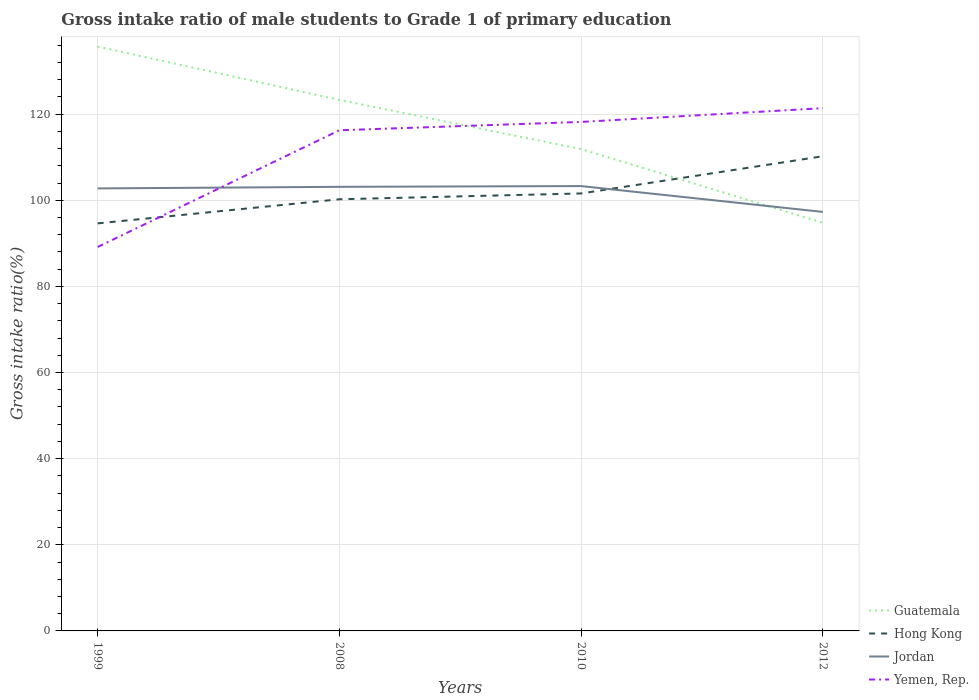Across all years, what is the maximum gross intake ratio in Hong Kong?
Your answer should be very brief. 94.64. In which year was the gross intake ratio in Guatemala maximum?
Offer a very short reply. 2012. What is the total gross intake ratio in Hong Kong in the graph?
Ensure brevity in your answer.  -15.59. What is the difference between the highest and the second highest gross intake ratio in Jordan?
Provide a succinct answer. 6. What is the difference between the highest and the lowest gross intake ratio in Yemen, Rep.?
Ensure brevity in your answer.  3. How many lines are there?
Keep it short and to the point. 4. How many years are there in the graph?
Keep it short and to the point. 4. What is the difference between two consecutive major ticks on the Y-axis?
Your answer should be compact. 20. Does the graph contain grids?
Provide a succinct answer. Yes. What is the title of the graph?
Make the answer very short. Gross intake ratio of male students to Grade 1 of primary education. What is the label or title of the Y-axis?
Make the answer very short. Gross intake ratio(%). What is the Gross intake ratio(%) in Guatemala in 1999?
Your answer should be very brief. 135.69. What is the Gross intake ratio(%) in Hong Kong in 1999?
Offer a terse response. 94.64. What is the Gross intake ratio(%) in Jordan in 1999?
Offer a terse response. 102.75. What is the Gross intake ratio(%) in Yemen, Rep. in 1999?
Offer a very short reply. 89.15. What is the Gross intake ratio(%) in Guatemala in 2008?
Offer a terse response. 123.3. What is the Gross intake ratio(%) in Hong Kong in 2008?
Give a very brief answer. 100.24. What is the Gross intake ratio(%) in Jordan in 2008?
Offer a terse response. 103.13. What is the Gross intake ratio(%) in Yemen, Rep. in 2008?
Your response must be concise. 116.26. What is the Gross intake ratio(%) in Guatemala in 2010?
Your response must be concise. 111.89. What is the Gross intake ratio(%) of Hong Kong in 2010?
Provide a succinct answer. 101.59. What is the Gross intake ratio(%) of Jordan in 2010?
Keep it short and to the point. 103.3. What is the Gross intake ratio(%) of Yemen, Rep. in 2010?
Offer a terse response. 118.19. What is the Gross intake ratio(%) in Guatemala in 2012?
Give a very brief answer. 94.78. What is the Gross intake ratio(%) of Hong Kong in 2012?
Your answer should be compact. 110.22. What is the Gross intake ratio(%) of Jordan in 2012?
Provide a succinct answer. 97.3. What is the Gross intake ratio(%) in Yemen, Rep. in 2012?
Your answer should be very brief. 121.39. Across all years, what is the maximum Gross intake ratio(%) in Guatemala?
Keep it short and to the point. 135.69. Across all years, what is the maximum Gross intake ratio(%) in Hong Kong?
Your answer should be very brief. 110.22. Across all years, what is the maximum Gross intake ratio(%) of Jordan?
Offer a very short reply. 103.3. Across all years, what is the maximum Gross intake ratio(%) of Yemen, Rep.?
Your answer should be compact. 121.39. Across all years, what is the minimum Gross intake ratio(%) in Guatemala?
Provide a succinct answer. 94.78. Across all years, what is the minimum Gross intake ratio(%) in Hong Kong?
Your answer should be compact. 94.64. Across all years, what is the minimum Gross intake ratio(%) of Jordan?
Your answer should be very brief. 97.3. Across all years, what is the minimum Gross intake ratio(%) in Yemen, Rep.?
Provide a short and direct response. 89.15. What is the total Gross intake ratio(%) of Guatemala in the graph?
Give a very brief answer. 465.66. What is the total Gross intake ratio(%) in Hong Kong in the graph?
Keep it short and to the point. 406.69. What is the total Gross intake ratio(%) in Jordan in the graph?
Your response must be concise. 406.48. What is the total Gross intake ratio(%) in Yemen, Rep. in the graph?
Give a very brief answer. 445. What is the difference between the Gross intake ratio(%) of Guatemala in 1999 and that in 2008?
Provide a short and direct response. 12.39. What is the difference between the Gross intake ratio(%) in Hong Kong in 1999 and that in 2008?
Your response must be concise. -5.6. What is the difference between the Gross intake ratio(%) of Jordan in 1999 and that in 2008?
Provide a short and direct response. -0.37. What is the difference between the Gross intake ratio(%) in Yemen, Rep. in 1999 and that in 2008?
Your response must be concise. -27.11. What is the difference between the Gross intake ratio(%) of Guatemala in 1999 and that in 2010?
Make the answer very short. 23.8. What is the difference between the Gross intake ratio(%) in Hong Kong in 1999 and that in 2010?
Your response must be concise. -6.95. What is the difference between the Gross intake ratio(%) in Jordan in 1999 and that in 2010?
Provide a short and direct response. -0.55. What is the difference between the Gross intake ratio(%) of Yemen, Rep. in 1999 and that in 2010?
Make the answer very short. -29.04. What is the difference between the Gross intake ratio(%) of Guatemala in 1999 and that in 2012?
Your response must be concise. 40.91. What is the difference between the Gross intake ratio(%) of Hong Kong in 1999 and that in 2012?
Provide a succinct answer. -15.59. What is the difference between the Gross intake ratio(%) of Jordan in 1999 and that in 2012?
Ensure brevity in your answer.  5.46. What is the difference between the Gross intake ratio(%) in Yemen, Rep. in 1999 and that in 2012?
Provide a succinct answer. -32.24. What is the difference between the Gross intake ratio(%) in Guatemala in 2008 and that in 2010?
Make the answer very short. 11.41. What is the difference between the Gross intake ratio(%) in Hong Kong in 2008 and that in 2010?
Provide a short and direct response. -1.35. What is the difference between the Gross intake ratio(%) of Jordan in 2008 and that in 2010?
Your answer should be compact. -0.17. What is the difference between the Gross intake ratio(%) in Yemen, Rep. in 2008 and that in 2010?
Offer a terse response. -1.93. What is the difference between the Gross intake ratio(%) in Guatemala in 2008 and that in 2012?
Provide a short and direct response. 28.53. What is the difference between the Gross intake ratio(%) of Hong Kong in 2008 and that in 2012?
Offer a terse response. -9.99. What is the difference between the Gross intake ratio(%) of Jordan in 2008 and that in 2012?
Give a very brief answer. 5.83. What is the difference between the Gross intake ratio(%) of Yemen, Rep. in 2008 and that in 2012?
Give a very brief answer. -5.13. What is the difference between the Gross intake ratio(%) in Guatemala in 2010 and that in 2012?
Your answer should be very brief. 17.12. What is the difference between the Gross intake ratio(%) of Hong Kong in 2010 and that in 2012?
Make the answer very short. -8.64. What is the difference between the Gross intake ratio(%) in Jordan in 2010 and that in 2012?
Offer a terse response. 6. What is the difference between the Gross intake ratio(%) of Yemen, Rep. in 2010 and that in 2012?
Make the answer very short. -3.2. What is the difference between the Gross intake ratio(%) of Guatemala in 1999 and the Gross intake ratio(%) of Hong Kong in 2008?
Your answer should be very brief. 35.45. What is the difference between the Gross intake ratio(%) of Guatemala in 1999 and the Gross intake ratio(%) of Jordan in 2008?
Offer a terse response. 32.56. What is the difference between the Gross intake ratio(%) of Guatemala in 1999 and the Gross intake ratio(%) of Yemen, Rep. in 2008?
Offer a very short reply. 19.43. What is the difference between the Gross intake ratio(%) of Hong Kong in 1999 and the Gross intake ratio(%) of Jordan in 2008?
Your answer should be very brief. -8.49. What is the difference between the Gross intake ratio(%) in Hong Kong in 1999 and the Gross intake ratio(%) in Yemen, Rep. in 2008?
Provide a short and direct response. -21.62. What is the difference between the Gross intake ratio(%) in Jordan in 1999 and the Gross intake ratio(%) in Yemen, Rep. in 2008?
Provide a succinct answer. -13.51. What is the difference between the Gross intake ratio(%) of Guatemala in 1999 and the Gross intake ratio(%) of Hong Kong in 2010?
Give a very brief answer. 34.1. What is the difference between the Gross intake ratio(%) in Guatemala in 1999 and the Gross intake ratio(%) in Jordan in 2010?
Make the answer very short. 32.39. What is the difference between the Gross intake ratio(%) in Guatemala in 1999 and the Gross intake ratio(%) in Yemen, Rep. in 2010?
Offer a very short reply. 17.5. What is the difference between the Gross intake ratio(%) in Hong Kong in 1999 and the Gross intake ratio(%) in Jordan in 2010?
Provide a succinct answer. -8.66. What is the difference between the Gross intake ratio(%) in Hong Kong in 1999 and the Gross intake ratio(%) in Yemen, Rep. in 2010?
Give a very brief answer. -23.56. What is the difference between the Gross intake ratio(%) of Jordan in 1999 and the Gross intake ratio(%) of Yemen, Rep. in 2010?
Provide a short and direct response. -15.44. What is the difference between the Gross intake ratio(%) in Guatemala in 1999 and the Gross intake ratio(%) in Hong Kong in 2012?
Provide a short and direct response. 25.47. What is the difference between the Gross intake ratio(%) in Guatemala in 1999 and the Gross intake ratio(%) in Jordan in 2012?
Offer a very short reply. 38.39. What is the difference between the Gross intake ratio(%) of Guatemala in 1999 and the Gross intake ratio(%) of Yemen, Rep. in 2012?
Ensure brevity in your answer.  14.3. What is the difference between the Gross intake ratio(%) in Hong Kong in 1999 and the Gross intake ratio(%) in Jordan in 2012?
Your response must be concise. -2.66. What is the difference between the Gross intake ratio(%) in Hong Kong in 1999 and the Gross intake ratio(%) in Yemen, Rep. in 2012?
Your answer should be very brief. -26.76. What is the difference between the Gross intake ratio(%) of Jordan in 1999 and the Gross intake ratio(%) of Yemen, Rep. in 2012?
Provide a succinct answer. -18.64. What is the difference between the Gross intake ratio(%) in Guatemala in 2008 and the Gross intake ratio(%) in Hong Kong in 2010?
Provide a short and direct response. 21.72. What is the difference between the Gross intake ratio(%) of Guatemala in 2008 and the Gross intake ratio(%) of Jordan in 2010?
Your answer should be compact. 20. What is the difference between the Gross intake ratio(%) in Guatemala in 2008 and the Gross intake ratio(%) in Yemen, Rep. in 2010?
Your response must be concise. 5.11. What is the difference between the Gross intake ratio(%) in Hong Kong in 2008 and the Gross intake ratio(%) in Jordan in 2010?
Ensure brevity in your answer.  -3.06. What is the difference between the Gross intake ratio(%) in Hong Kong in 2008 and the Gross intake ratio(%) in Yemen, Rep. in 2010?
Make the answer very short. -17.96. What is the difference between the Gross intake ratio(%) in Jordan in 2008 and the Gross intake ratio(%) in Yemen, Rep. in 2010?
Keep it short and to the point. -15.07. What is the difference between the Gross intake ratio(%) of Guatemala in 2008 and the Gross intake ratio(%) of Hong Kong in 2012?
Provide a short and direct response. 13.08. What is the difference between the Gross intake ratio(%) of Guatemala in 2008 and the Gross intake ratio(%) of Jordan in 2012?
Offer a very short reply. 26. What is the difference between the Gross intake ratio(%) in Guatemala in 2008 and the Gross intake ratio(%) in Yemen, Rep. in 2012?
Offer a terse response. 1.91. What is the difference between the Gross intake ratio(%) of Hong Kong in 2008 and the Gross intake ratio(%) of Jordan in 2012?
Ensure brevity in your answer.  2.94. What is the difference between the Gross intake ratio(%) of Hong Kong in 2008 and the Gross intake ratio(%) of Yemen, Rep. in 2012?
Your response must be concise. -21.15. What is the difference between the Gross intake ratio(%) of Jordan in 2008 and the Gross intake ratio(%) of Yemen, Rep. in 2012?
Keep it short and to the point. -18.27. What is the difference between the Gross intake ratio(%) in Guatemala in 2010 and the Gross intake ratio(%) in Hong Kong in 2012?
Your response must be concise. 1.67. What is the difference between the Gross intake ratio(%) in Guatemala in 2010 and the Gross intake ratio(%) in Jordan in 2012?
Ensure brevity in your answer.  14.59. What is the difference between the Gross intake ratio(%) in Guatemala in 2010 and the Gross intake ratio(%) in Yemen, Rep. in 2012?
Offer a terse response. -9.5. What is the difference between the Gross intake ratio(%) of Hong Kong in 2010 and the Gross intake ratio(%) of Jordan in 2012?
Ensure brevity in your answer.  4.29. What is the difference between the Gross intake ratio(%) of Hong Kong in 2010 and the Gross intake ratio(%) of Yemen, Rep. in 2012?
Provide a short and direct response. -19.81. What is the difference between the Gross intake ratio(%) in Jordan in 2010 and the Gross intake ratio(%) in Yemen, Rep. in 2012?
Keep it short and to the point. -18.09. What is the average Gross intake ratio(%) in Guatemala per year?
Offer a very short reply. 116.42. What is the average Gross intake ratio(%) of Hong Kong per year?
Make the answer very short. 101.67. What is the average Gross intake ratio(%) of Jordan per year?
Provide a short and direct response. 101.62. What is the average Gross intake ratio(%) of Yemen, Rep. per year?
Ensure brevity in your answer.  111.25. In the year 1999, what is the difference between the Gross intake ratio(%) of Guatemala and Gross intake ratio(%) of Hong Kong?
Offer a terse response. 41.05. In the year 1999, what is the difference between the Gross intake ratio(%) in Guatemala and Gross intake ratio(%) in Jordan?
Your answer should be compact. 32.94. In the year 1999, what is the difference between the Gross intake ratio(%) in Guatemala and Gross intake ratio(%) in Yemen, Rep.?
Provide a short and direct response. 46.54. In the year 1999, what is the difference between the Gross intake ratio(%) of Hong Kong and Gross intake ratio(%) of Jordan?
Make the answer very short. -8.12. In the year 1999, what is the difference between the Gross intake ratio(%) in Hong Kong and Gross intake ratio(%) in Yemen, Rep.?
Your answer should be compact. 5.48. In the year 1999, what is the difference between the Gross intake ratio(%) in Jordan and Gross intake ratio(%) in Yemen, Rep.?
Offer a very short reply. 13.6. In the year 2008, what is the difference between the Gross intake ratio(%) in Guatemala and Gross intake ratio(%) in Hong Kong?
Give a very brief answer. 23.06. In the year 2008, what is the difference between the Gross intake ratio(%) of Guatemala and Gross intake ratio(%) of Jordan?
Your answer should be very brief. 20.18. In the year 2008, what is the difference between the Gross intake ratio(%) in Guatemala and Gross intake ratio(%) in Yemen, Rep.?
Give a very brief answer. 7.04. In the year 2008, what is the difference between the Gross intake ratio(%) of Hong Kong and Gross intake ratio(%) of Jordan?
Ensure brevity in your answer.  -2.89. In the year 2008, what is the difference between the Gross intake ratio(%) in Hong Kong and Gross intake ratio(%) in Yemen, Rep.?
Your response must be concise. -16.02. In the year 2008, what is the difference between the Gross intake ratio(%) in Jordan and Gross intake ratio(%) in Yemen, Rep.?
Provide a succinct answer. -13.13. In the year 2010, what is the difference between the Gross intake ratio(%) of Guatemala and Gross intake ratio(%) of Hong Kong?
Offer a very short reply. 10.31. In the year 2010, what is the difference between the Gross intake ratio(%) in Guatemala and Gross intake ratio(%) in Jordan?
Your response must be concise. 8.59. In the year 2010, what is the difference between the Gross intake ratio(%) in Guatemala and Gross intake ratio(%) in Yemen, Rep.?
Offer a very short reply. -6.3. In the year 2010, what is the difference between the Gross intake ratio(%) of Hong Kong and Gross intake ratio(%) of Jordan?
Provide a succinct answer. -1.71. In the year 2010, what is the difference between the Gross intake ratio(%) of Hong Kong and Gross intake ratio(%) of Yemen, Rep.?
Your answer should be compact. -16.61. In the year 2010, what is the difference between the Gross intake ratio(%) in Jordan and Gross intake ratio(%) in Yemen, Rep.?
Keep it short and to the point. -14.89. In the year 2012, what is the difference between the Gross intake ratio(%) in Guatemala and Gross intake ratio(%) in Hong Kong?
Give a very brief answer. -15.45. In the year 2012, what is the difference between the Gross intake ratio(%) in Guatemala and Gross intake ratio(%) in Jordan?
Your response must be concise. -2.52. In the year 2012, what is the difference between the Gross intake ratio(%) in Guatemala and Gross intake ratio(%) in Yemen, Rep.?
Give a very brief answer. -26.62. In the year 2012, what is the difference between the Gross intake ratio(%) of Hong Kong and Gross intake ratio(%) of Jordan?
Your answer should be very brief. 12.93. In the year 2012, what is the difference between the Gross intake ratio(%) in Hong Kong and Gross intake ratio(%) in Yemen, Rep.?
Provide a short and direct response. -11.17. In the year 2012, what is the difference between the Gross intake ratio(%) in Jordan and Gross intake ratio(%) in Yemen, Rep.?
Give a very brief answer. -24.09. What is the ratio of the Gross intake ratio(%) of Guatemala in 1999 to that in 2008?
Ensure brevity in your answer.  1.1. What is the ratio of the Gross intake ratio(%) in Hong Kong in 1999 to that in 2008?
Provide a short and direct response. 0.94. What is the ratio of the Gross intake ratio(%) of Yemen, Rep. in 1999 to that in 2008?
Make the answer very short. 0.77. What is the ratio of the Gross intake ratio(%) in Guatemala in 1999 to that in 2010?
Your answer should be very brief. 1.21. What is the ratio of the Gross intake ratio(%) of Hong Kong in 1999 to that in 2010?
Offer a terse response. 0.93. What is the ratio of the Gross intake ratio(%) of Jordan in 1999 to that in 2010?
Provide a succinct answer. 0.99. What is the ratio of the Gross intake ratio(%) of Yemen, Rep. in 1999 to that in 2010?
Make the answer very short. 0.75. What is the ratio of the Gross intake ratio(%) of Guatemala in 1999 to that in 2012?
Offer a terse response. 1.43. What is the ratio of the Gross intake ratio(%) in Hong Kong in 1999 to that in 2012?
Give a very brief answer. 0.86. What is the ratio of the Gross intake ratio(%) of Jordan in 1999 to that in 2012?
Provide a short and direct response. 1.06. What is the ratio of the Gross intake ratio(%) of Yemen, Rep. in 1999 to that in 2012?
Offer a terse response. 0.73. What is the ratio of the Gross intake ratio(%) of Guatemala in 2008 to that in 2010?
Offer a very short reply. 1.1. What is the ratio of the Gross intake ratio(%) of Hong Kong in 2008 to that in 2010?
Your response must be concise. 0.99. What is the ratio of the Gross intake ratio(%) in Yemen, Rep. in 2008 to that in 2010?
Your response must be concise. 0.98. What is the ratio of the Gross intake ratio(%) of Guatemala in 2008 to that in 2012?
Ensure brevity in your answer.  1.3. What is the ratio of the Gross intake ratio(%) of Hong Kong in 2008 to that in 2012?
Offer a very short reply. 0.91. What is the ratio of the Gross intake ratio(%) in Jordan in 2008 to that in 2012?
Your response must be concise. 1.06. What is the ratio of the Gross intake ratio(%) of Yemen, Rep. in 2008 to that in 2012?
Your answer should be compact. 0.96. What is the ratio of the Gross intake ratio(%) in Guatemala in 2010 to that in 2012?
Give a very brief answer. 1.18. What is the ratio of the Gross intake ratio(%) in Hong Kong in 2010 to that in 2012?
Ensure brevity in your answer.  0.92. What is the ratio of the Gross intake ratio(%) in Jordan in 2010 to that in 2012?
Provide a succinct answer. 1.06. What is the ratio of the Gross intake ratio(%) in Yemen, Rep. in 2010 to that in 2012?
Offer a very short reply. 0.97. What is the difference between the highest and the second highest Gross intake ratio(%) in Guatemala?
Ensure brevity in your answer.  12.39. What is the difference between the highest and the second highest Gross intake ratio(%) in Hong Kong?
Offer a very short reply. 8.64. What is the difference between the highest and the second highest Gross intake ratio(%) in Jordan?
Offer a very short reply. 0.17. What is the difference between the highest and the second highest Gross intake ratio(%) in Yemen, Rep.?
Provide a short and direct response. 3.2. What is the difference between the highest and the lowest Gross intake ratio(%) of Guatemala?
Make the answer very short. 40.91. What is the difference between the highest and the lowest Gross intake ratio(%) of Hong Kong?
Make the answer very short. 15.59. What is the difference between the highest and the lowest Gross intake ratio(%) of Jordan?
Make the answer very short. 6. What is the difference between the highest and the lowest Gross intake ratio(%) in Yemen, Rep.?
Ensure brevity in your answer.  32.24. 